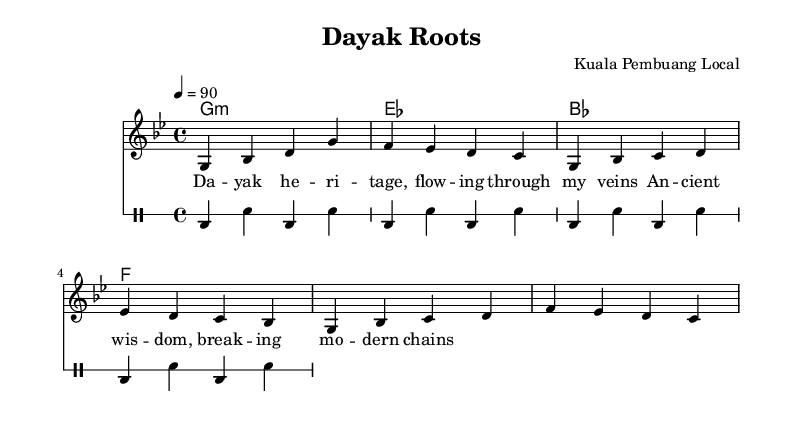What is the key signature of this music? The key signature is represented by the 'g minor' indication at the beginning of the sheet music. This is typically noted near the clef at the start of the staff in the sheet music.
Answer: g minor What is the time signature of this music? The time signature is indicated as '4/4', which tells us there are four beats per measure, and the quarter note gets one beat. This is found at the beginning of the staff before the melody starts.
Answer: 4/4 What is the tempo marking of this music? The tempo marking is indicated as '4 = 90', meaning that the quarter note should be played at a speed of 90 beats per minute. This information can be found in the tempo section at the start of the piece.
Answer: 90 How many measures are in the melody part? By counting the individual measures in the melody part, we see there are 8 measures listed in the melody notation. Each segment is separated by a vertical line that indicates the end of a measure.
Answer: 8 What is the first lyric line of the song? The first line consists of the words shown beneath the notes of the melody. It begins with "Dayak heritage, flowing through my veins." This line is visible in the lyrics section of the sheet music.
Answer: "Dayak heritage, flowing through my veins." What music style is represented in this sheet music? The overall structure and lyrical theme indicate that it is rap music, characterized by rhythmic and rhymed verses. This style is further represented through the use of a drum section, which complements the vocal lines typical in rap compositions.
Answer: Rap 